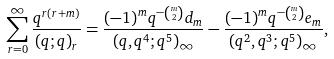<formula> <loc_0><loc_0><loc_500><loc_500>\sum _ { r = 0 } ^ { \infty } \frac { q ^ { r ( r + m ) } } { ( q ; q ) _ { r } } = \frac { ( - 1 ) ^ { m } q ^ { - \binom { m } { 2 } } d _ { m } } { ( q , q ^ { 4 } ; q ^ { 5 } ) _ { \infty } } - \frac { ( - 1 ) ^ { m } q ^ { - \binom { m } { 2 } } e _ { m } } { ( q ^ { 2 } , q ^ { 3 } ; q ^ { 5 } ) _ { \infty } } ,</formula> 